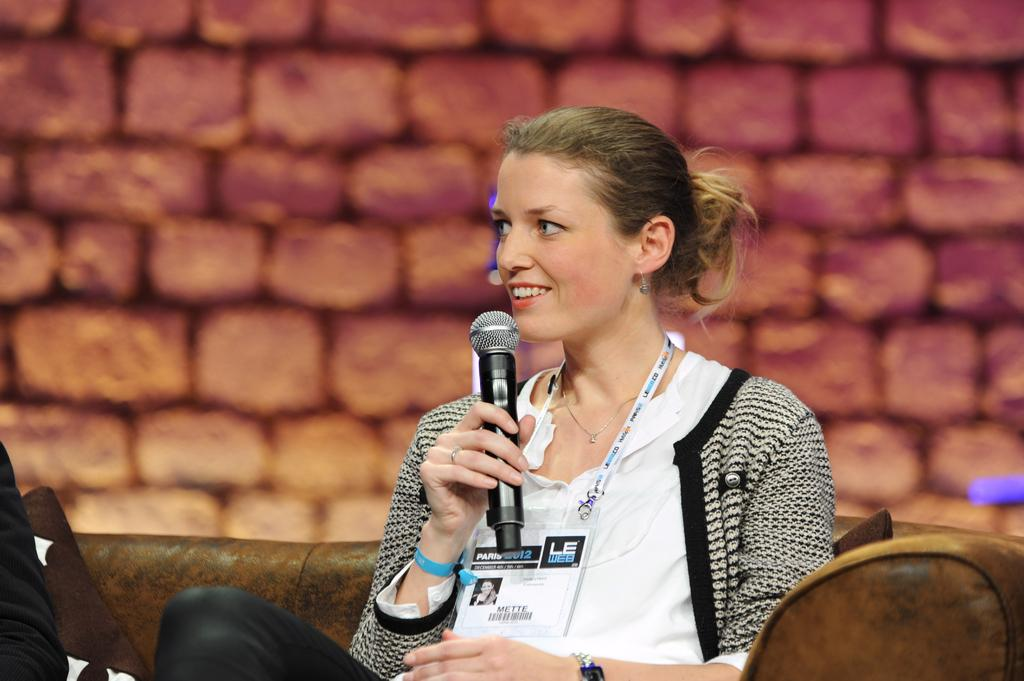Who is the main subject in the image? There is a woman in the image. What is the woman doing in the image? The woman is sitting in the image. What object is the woman holding in her hand? The woman is holding a microphone in her hand. What verse from the week's sermon is the woman reciting in the image? There is no indication in the image that the woman is reciting a verse from a sermon, and therefore no such activity can be observed. 